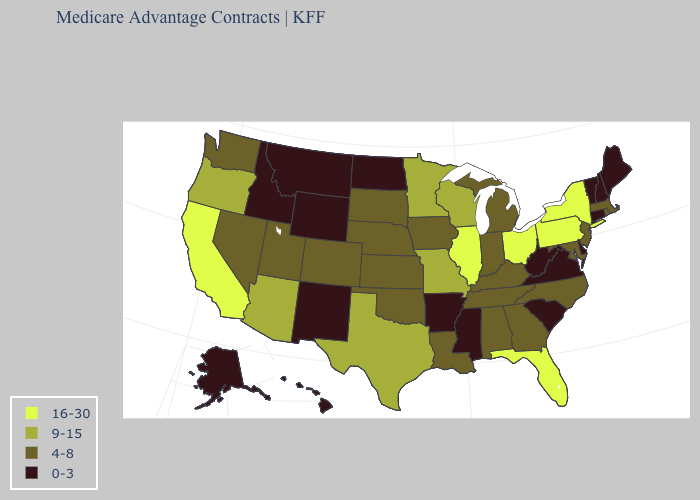Name the states that have a value in the range 0-3?
Short answer required. Alaska, Arkansas, Connecticut, Delaware, Hawaii, Idaho, Maine, Mississippi, Montana, North Dakota, New Hampshire, New Mexico, South Carolina, Virginia, Vermont, West Virginia, Wyoming. What is the highest value in the MidWest ?
Short answer required. 16-30. Name the states that have a value in the range 0-3?
Be succinct. Alaska, Arkansas, Connecticut, Delaware, Hawaii, Idaho, Maine, Mississippi, Montana, North Dakota, New Hampshire, New Mexico, South Carolina, Virginia, Vermont, West Virginia, Wyoming. What is the highest value in the USA?
Concise answer only. 16-30. What is the highest value in the West ?
Give a very brief answer. 16-30. What is the highest value in the USA?
Write a very short answer. 16-30. What is the value of New York?
Concise answer only. 16-30. What is the value of Minnesota?
Give a very brief answer. 9-15. What is the lowest value in the USA?
Keep it brief. 0-3. What is the value of Texas?
Write a very short answer. 9-15. What is the lowest value in states that border Tennessee?
Give a very brief answer. 0-3. What is the value of Hawaii?
Give a very brief answer. 0-3. Does Maine have the lowest value in the Northeast?
Answer briefly. Yes. What is the lowest value in the USA?
Answer briefly. 0-3. What is the value of Maryland?
Concise answer only. 4-8. 